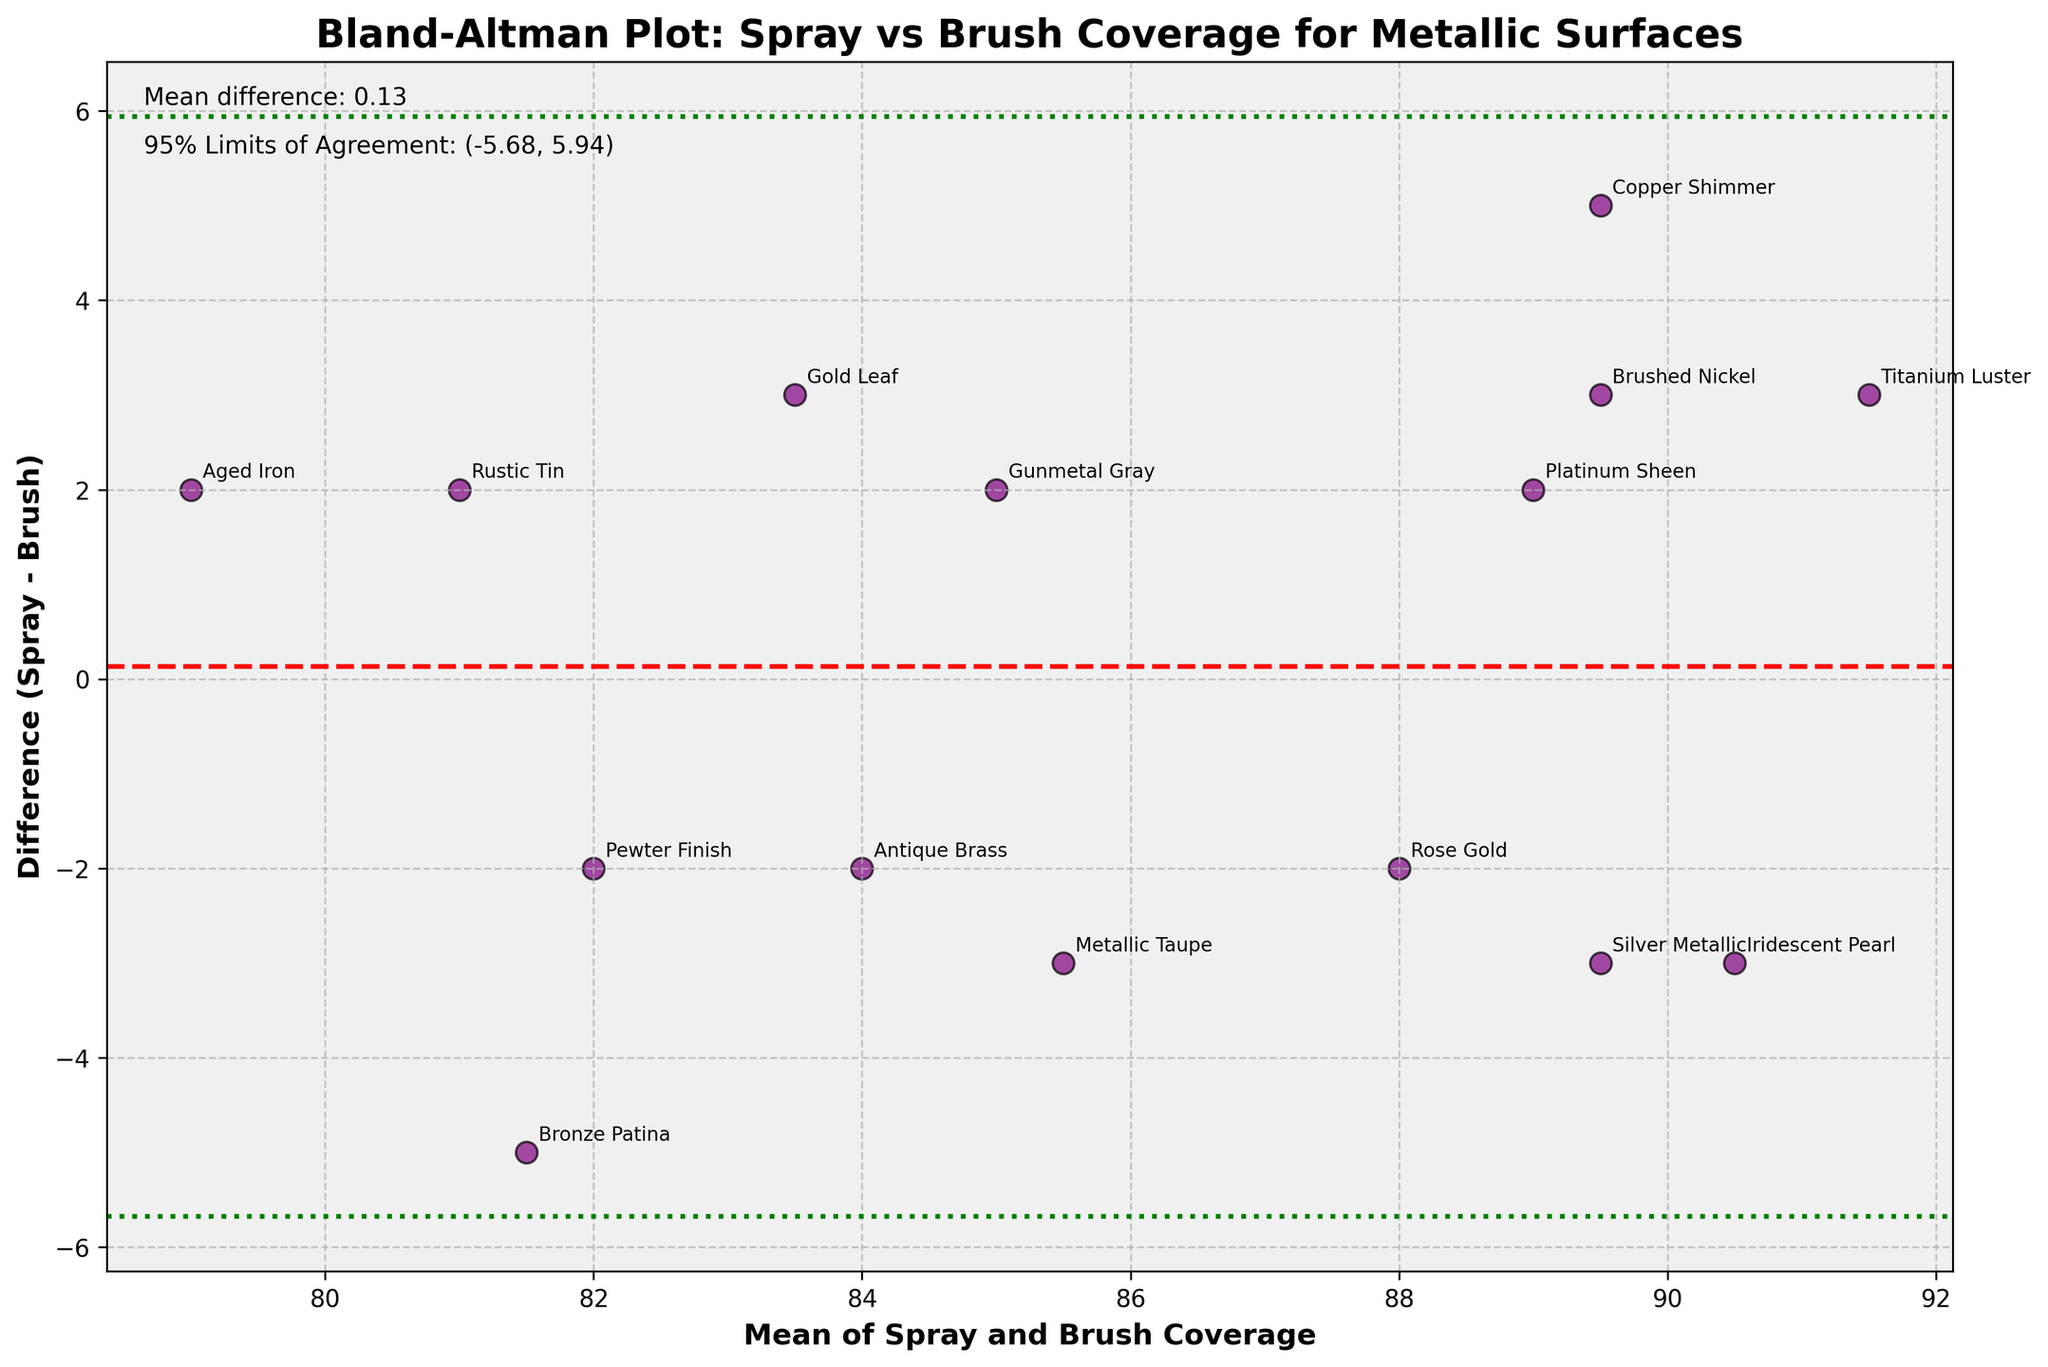What is the title of the plot? The title of the plot is typically the large, bold text at the top. It gives an overview of what the plot represents. In this case, the title is "Bland-Altman Plot: Spray vs Brush Coverage for Metallic Surfaces."
Answer: Bland-Altman Plot: Spray vs Brush Coverage for Metallic Surfaces How many data points are plotted? The number of data points can be counted by looking at the number of individual markers on the scatter plot. In this case, each method (e.g., Gold Leaf, Silver Metallic) represents one data point. There are 15 markers plotted, so there are 15 data points.
Answer: 15 Which method has the highest average coverage? To determine this, look for the data point with the highest value on the x-axis, which represents the "Average Coverage" value. The data point corresponding to "Titanium Luster" has the highest average coverage with a value of 91.5.
Answer: Titanium Luster What is the mean difference in coverage between spray and brush methods? The mean difference is indicated by the red dashed horizontal line in the plot. According to the plot, the mean difference value is also provided as text, which is approximately 0.33.
Answer: 0.33 Which product shows the largest difference in coverage between spray and brush methods? The largest difference can be identified by finding the data point furthest away from the zero difference line on the y-axis. "Copper Shimmer" has the largest difference, which appears to be 5 (Spray 92 - Brush 87).
Answer: Copper Shimmer What are the 95% limits of agreement for the differences in coverage? The 95% limits of agreement are marked by the green dotted horizontal lines. The values are also stated in the text within the plot, which are approximately (-5.39, 6.05).
Answer: (-5.39, 6.05) Which product has a higher coverage using the brush method compared to the spray method? To find this, look for data points below the zero difference line on the y-axis (negative values). "Silver Metallic," "Bronze Patina," and "Metallic Taupe" are examples where the brush coverage is higher than the spray coverage.
Answer: Silver Metallic, Bronze Patina, and Metallic Taupe What is the difference in coverage between spray and brush methods for the "Gold Leaf" product? To determine this, locate the "Gold Leaf" data point on the plot and read off the y-axis value, which represents the difference (Spray - Brush). The "Gold Leaf" product shows a difference of 3 (85 - 82).
Answer: 3 What does the x-axis represent in this plot? The x-axis represents the "Mean of Spray and Brush Coverage," which is the average coverage between the spray and brush methods for each product.
Answer: Mean of Spray and Brush Coverage What can you conclude if most of the differences fall within the 95% limits of agreement? If most differences fall within the 95% limits of agreement (indicated by two green dotted lines), it suggests that the coverage measurements between spray and brush methods are generally consistent and not significantly different beyond expected random variation. This is typical in a Bland-Altman plot to show that the methods can be used interchangeably.
Answer: The coverage measurements are generally consistent and not significantly different beyond expected random variation 